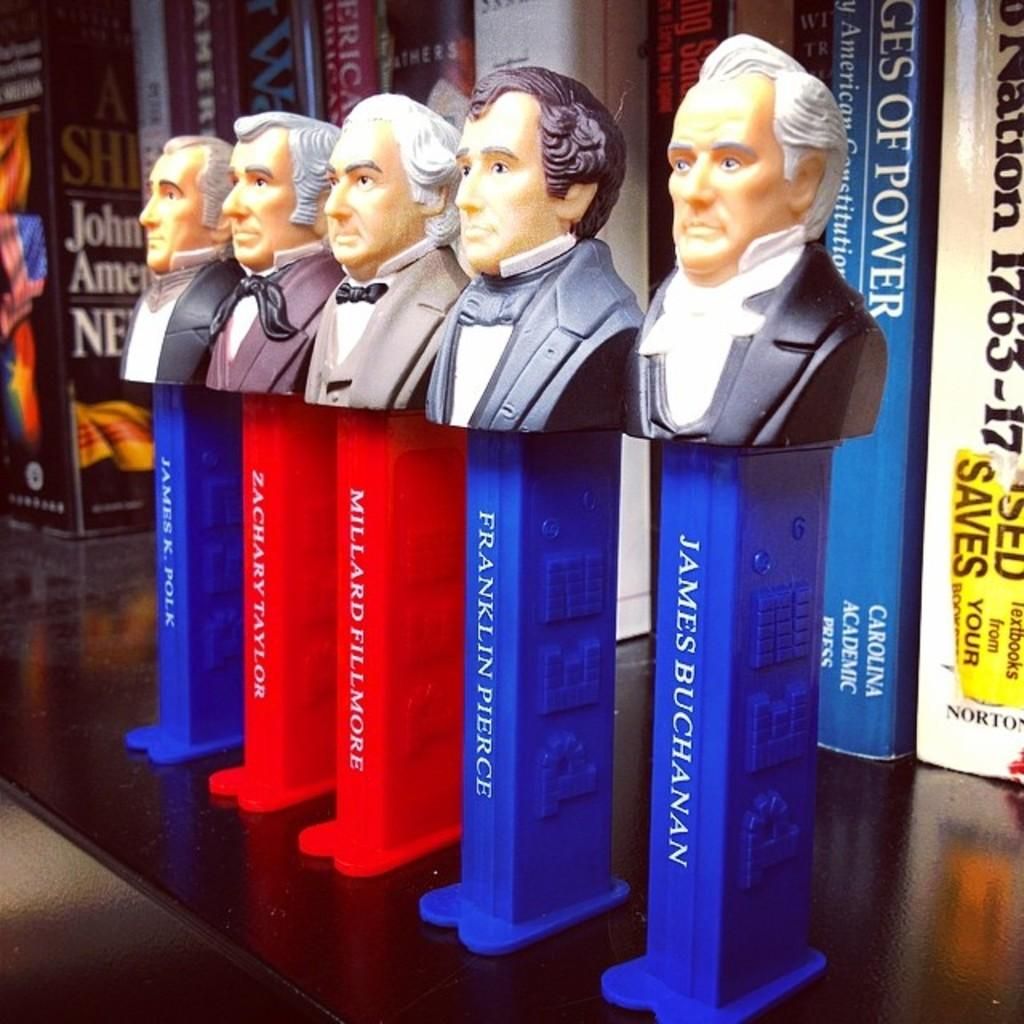Provide a one-sentence caption for the provided image. A row of pez dispensers of US presidents with James Buchanan on the right. 